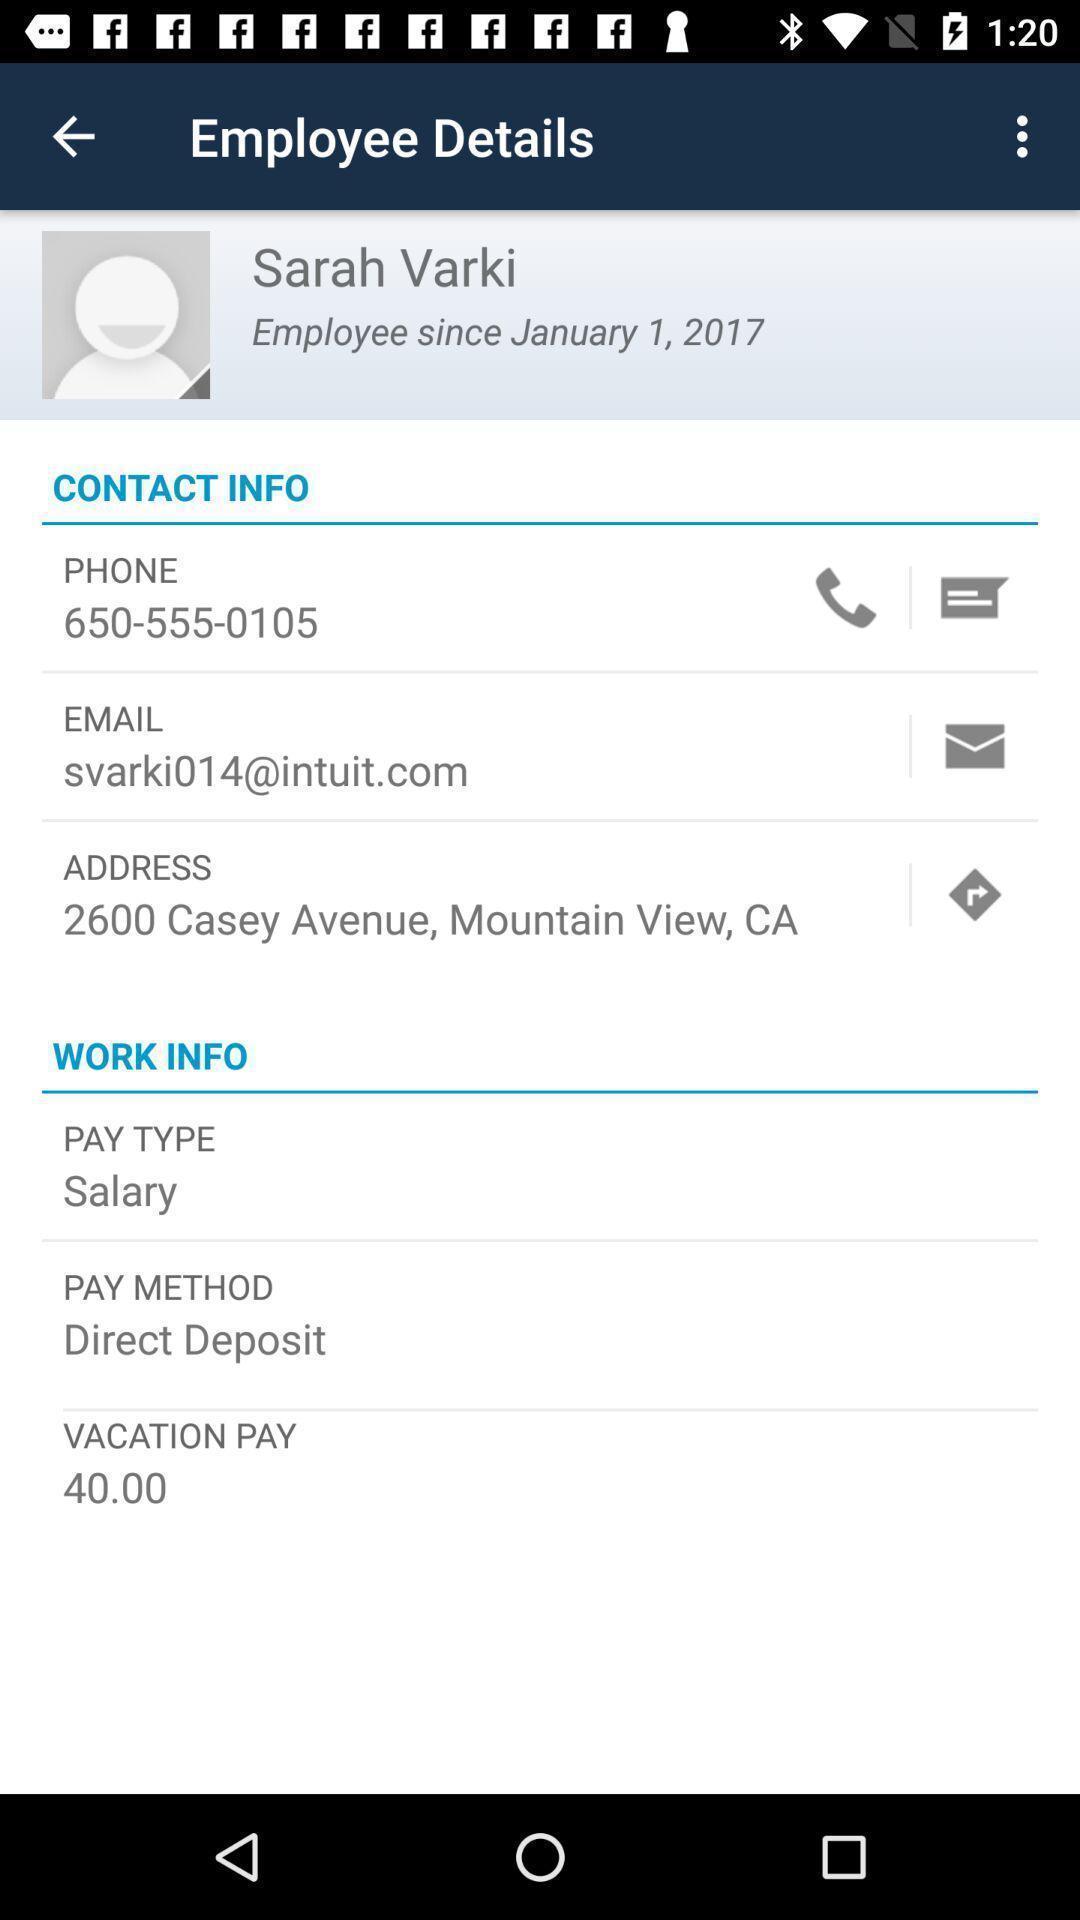Give me a narrative description of this picture. Page displaying the profile details licaton. 